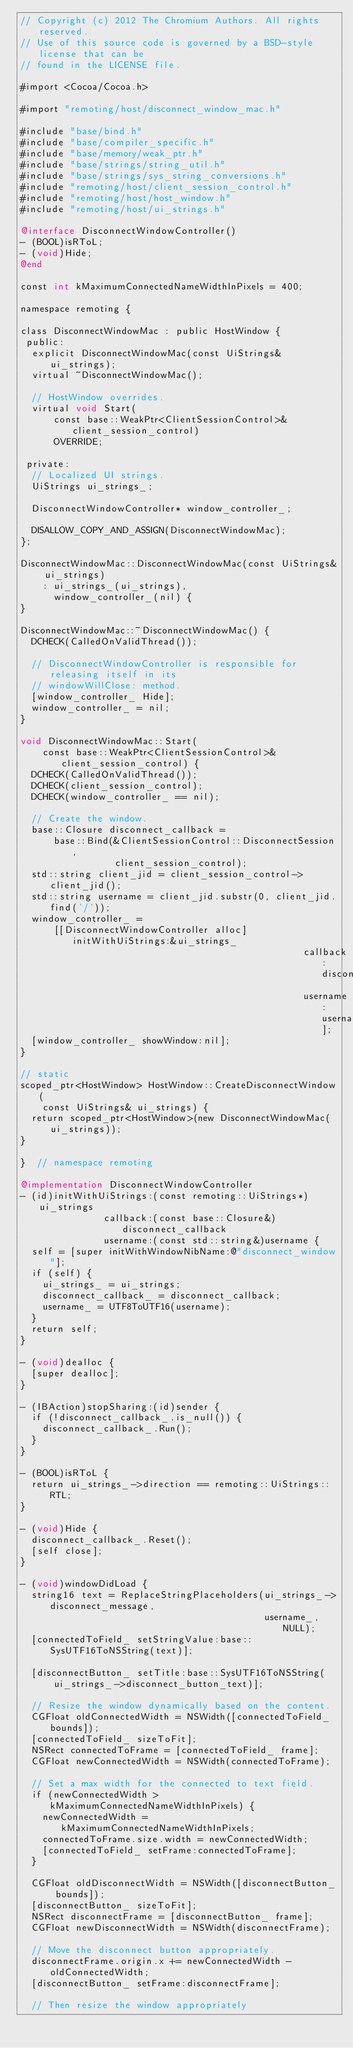<code> <loc_0><loc_0><loc_500><loc_500><_ObjectiveC_>// Copyright (c) 2012 The Chromium Authors. All rights reserved.
// Use of this source code is governed by a BSD-style license that can be
// found in the LICENSE file.

#import <Cocoa/Cocoa.h>

#import "remoting/host/disconnect_window_mac.h"

#include "base/bind.h"
#include "base/compiler_specific.h"
#include "base/memory/weak_ptr.h"
#include "base/strings/string_util.h"
#include "base/strings/sys_string_conversions.h"
#include "remoting/host/client_session_control.h"
#include "remoting/host/host_window.h"
#include "remoting/host/ui_strings.h"

@interface DisconnectWindowController()
- (BOOL)isRToL;
- (void)Hide;
@end

const int kMaximumConnectedNameWidthInPixels = 400;

namespace remoting {

class DisconnectWindowMac : public HostWindow {
 public:
  explicit DisconnectWindowMac(const UiStrings& ui_strings);
  virtual ~DisconnectWindowMac();

  // HostWindow overrides.
  virtual void Start(
      const base::WeakPtr<ClientSessionControl>& client_session_control)
      OVERRIDE;

 private:
  // Localized UI strings.
  UiStrings ui_strings_;

  DisconnectWindowController* window_controller_;

  DISALLOW_COPY_AND_ASSIGN(DisconnectWindowMac);
};

DisconnectWindowMac::DisconnectWindowMac(const UiStrings& ui_strings)
    : ui_strings_(ui_strings),
      window_controller_(nil) {
}

DisconnectWindowMac::~DisconnectWindowMac() {
  DCHECK(CalledOnValidThread());

  // DisconnectWindowController is responsible for releasing itself in its
  // windowWillClose: method.
  [window_controller_ Hide];
  window_controller_ = nil;
}

void DisconnectWindowMac::Start(
    const base::WeakPtr<ClientSessionControl>& client_session_control) {
  DCHECK(CalledOnValidThread());
  DCHECK(client_session_control);
  DCHECK(window_controller_ == nil);

  // Create the window.
  base::Closure disconnect_callback =
      base::Bind(&ClientSessionControl::DisconnectSession,
                 client_session_control);
  std::string client_jid = client_session_control->client_jid();
  std::string username = client_jid.substr(0, client_jid.find('/'));
  window_controller_ =
      [[DisconnectWindowController alloc] initWithUiStrings:&ui_strings_
                                                   callback:disconnect_callback
                                                   username:username];
  [window_controller_ showWindow:nil];
}

// static
scoped_ptr<HostWindow> HostWindow::CreateDisconnectWindow(
    const UiStrings& ui_strings) {
  return scoped_ptr<HostWindow>(new DisconnectWindowMac(ui_strings));
}

}  // namespace remoting

@implementation DisconnectWindowController
- (id)initWithUiStrings:(const remoting::UiStrings*)ui_strings
               callback:(const base::Closure&)disconnect_callback
               username:(const std::string&)username {
  self = [super initWithWindowNibName:@"disconnect_window"];
  if (self) {
    ui_strings_ = ui_strings;
    disconnect_callback_ = disconnect_callback;
    username_ = UTF8ToUTF16(username);
  }
  return self;
}

- (void)dealloc {
  [super dealloc];
}

- (IBAction)stopSharing:(id)sender {
  if (!disconnect_callback_.is_null()) {
    disconnect_callback_.Run();
  }
}

- (BOOL)isRToL {
  return ui_strings_->direction == remoting::UiStrings::RTL;
}

- (void)Hide {
  disconnect_callback_.Reset();
  [self close];
}

- (void)windowDidLoad {
  string16 text = ReplaceStringPlaceholders(ui_strings_->disconnect_message,
                                            username_, NULL);
  [connectedToField_ setStringValue:base::SysUTF16ToNSString(text)];

  [disconnectButton_ setTitle:base::SysUTF16ToNSString(
      ui_strings_->disconnect_button_text)];

  // Resize the window dynamically based on the content.
  CGFloat oldConnectedWidth = NSWidth([connectedToField_ bounds]);
  [connectedToField_ sizeToFit];
  NSRect connectedToFrame = [connectedToField_ frame];
  CGFloat newConnectedWidth = NSWidth(connectedToFrame);

  // Set a max width for the connected to text field.
  if (newConnectedWidth > kMaximumConnectedNameWidthInPixels) {
    newConnectedWidth = kMaximumConnectedNameWidthInPixels;
    connectedToFrame.size.width = newConnectedWidth;
    [connectedToField_ setFrame:connectedToFrame];
  }

  CGFloat oldDisconnectWidth = NSWidth([disconnectButton_ bounds]);
  [disconnectButton_ sizeToFit];
  NSRect disconnectFrame = [disconnectButton_ frame];
  CGFloat newDisconnectWidth = NSWidth(disconnectFrame);

  // Move the disconnect button appropriately.
  disconnectFrame.origin.x += newConnectedWidth - oldConnectedWidth;
  [disconnectButton_ setFrame:disconnectFrame];

  // Then resize the window appropriately</code> 